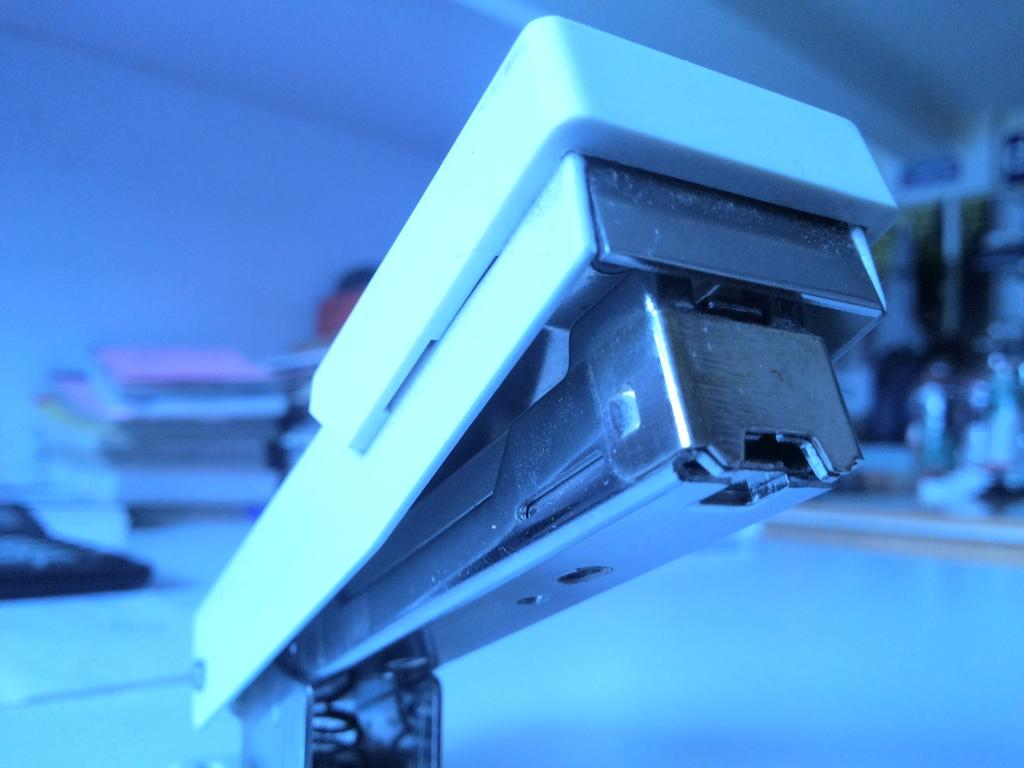What object can be seen in the image? There is a stapler in the image. How would you describe the quality of the background in the image? The background of the image is blurry. What color tone is dominant in the image? The image has a blue color tone. What type of church can be seen in the image? There is no church present in the image; it only features a stapler. What suggestions can be made based on the image? The image does not provide any information that would allow for suggestions to be made. 